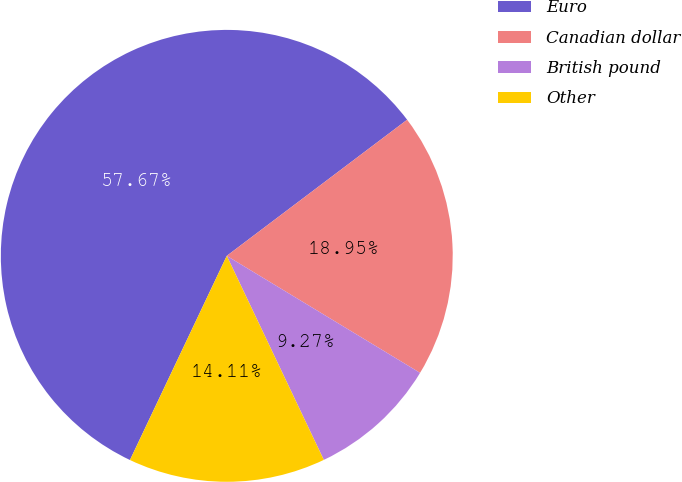Convert chart. <chart><loc_0><loc_0><loc_500><loc_500><pie_chart><fcel>Euro<fcel>Canadian dollar<fcel>British pound<fcel>Other<nl><fcel>57.66%<fcel>18.95%<fcel>9.27%<fcel>14.11%<nl></chart> 